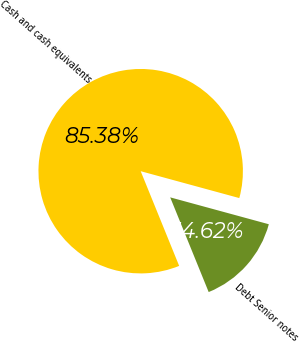<chart> <loc_0><loc_0><loc_500><loc_500><pie_chart><fcel>Cash and cash equivalents<fcel>Debt Senior notes<nl><fcel>85.38%<fcel>14.62%<nl></chart> 